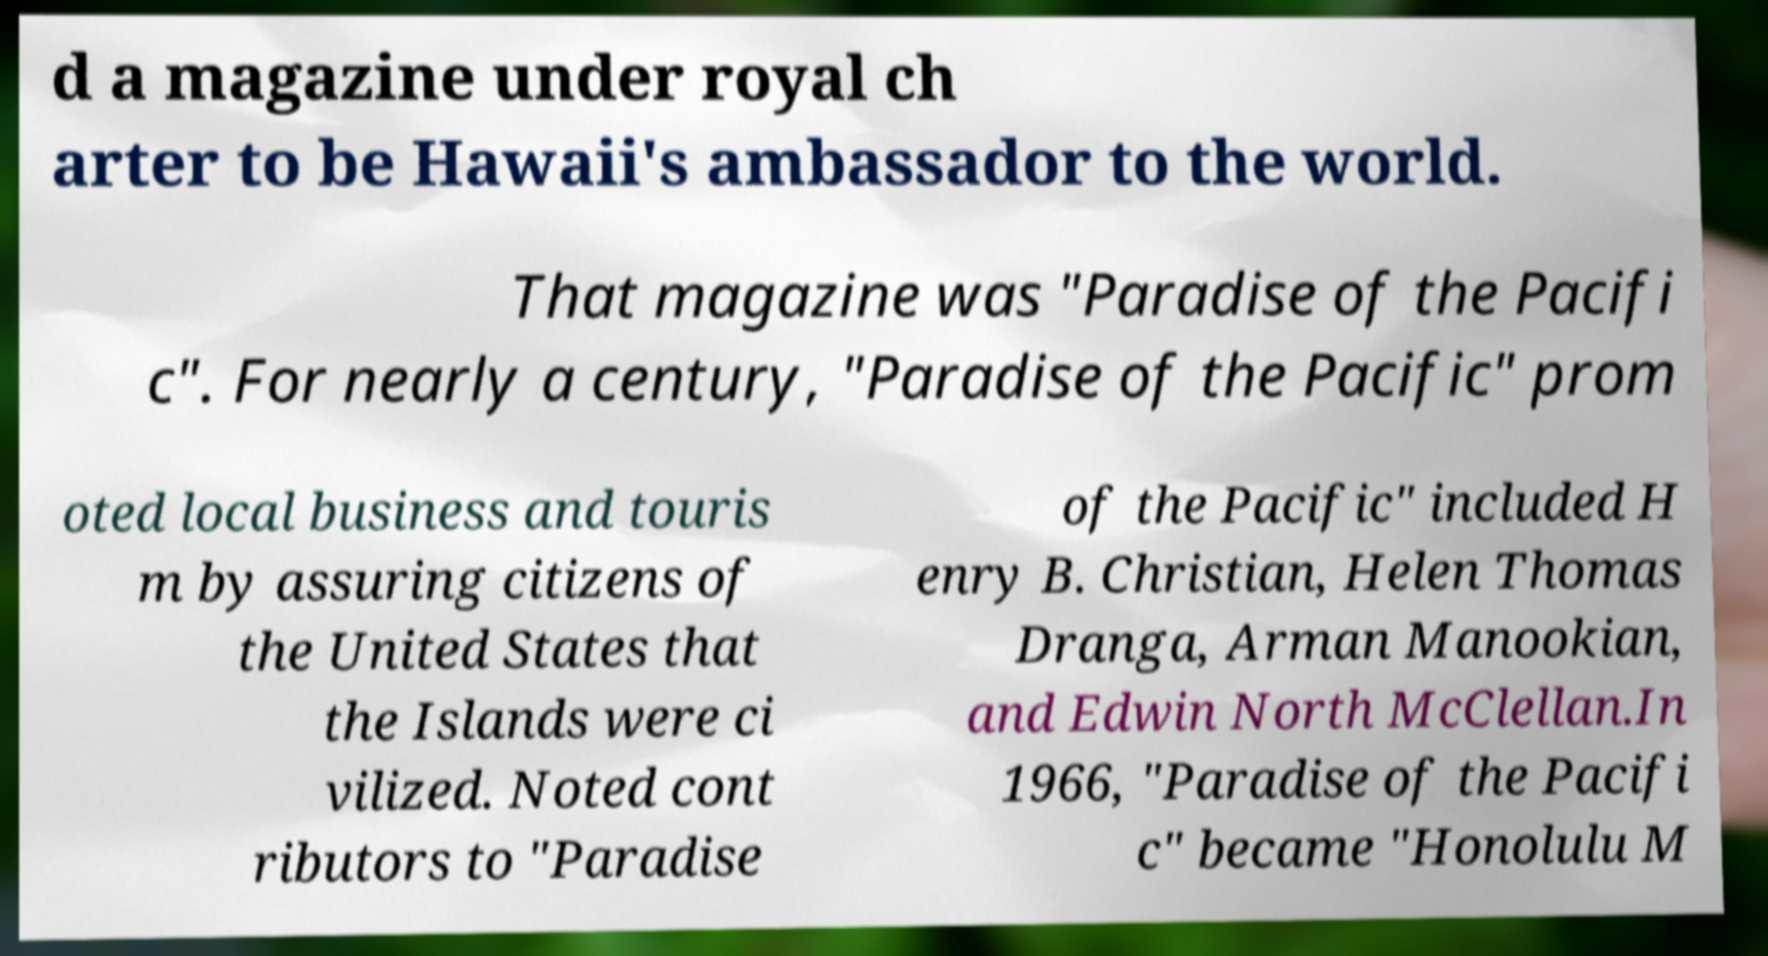There's text embedded in this image that I need extracted. Can you transcribe it verbatim? d a magazine under royal ch arter to be Hawaii's ambassador to the world. That magazine was "Paradise of the Pacifi c". For nearly a century, "Paradise of the Pacific" prom oted local business and touris m by assuring citizens of the United States that the Islands were ci vilized. Noted cont ributors to "Paradise of the Pacific" included H enry B. Christian, Helen Thomas Dranga, Arman Manookian, and Edwin North McClellan.In 1966, "Paradise of the Pacifi c" became "Honolulu M 